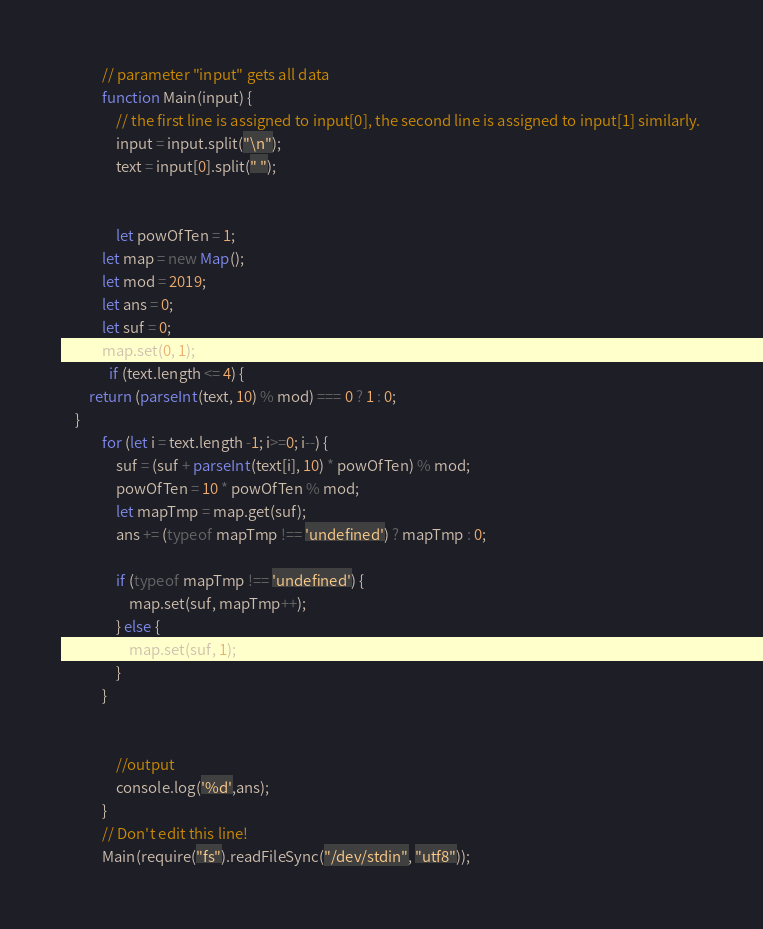<code> <loc_0><loc_0><loc_500><loc_500><_JavaScript_>            // parameter "input" gets all data
            function Main(input) {
            	// the first line is assigned to input[0], the second line is assigned to input[1] similarly.
            	input = input.split("\n");
            	text = input[0].split(" ");
            	
             
              	let powOfTen = 1;
        	let map = new Map();
        	let mod = 2019;
        	let ans = 0;
        	let suf = 0;
        	map.set(0, 1);
              if (text.length <= 4) {
		return (parseInt(text, 10) % mod) === 0 ? 1 : 0; 
	}
        	for (let i = text.length -1; i>=0; i--) {
        		suf = (suf + parseInt(text[i], 10) * powOfTen) % mod;
        		powOfTen = 10 * powOfTen % mod;
        		let mapTmp = map.get(suf);
        		ans += (typeof mapTmp !== 'undefined') ? mapTmp : 0;
        		
        		if (typeof mapTmp !== 'undefined') {
        			map.set(suf, mapTmp++);
        		} else {
        			map.set(suf, 1);
        		}
        	}
         
              
            	//output
            	console.log('%d',ans);
            }
            // Don't edit this line!
            Main(require("fs").readFileSync("/dev/stdin", "utf8"));</code> 